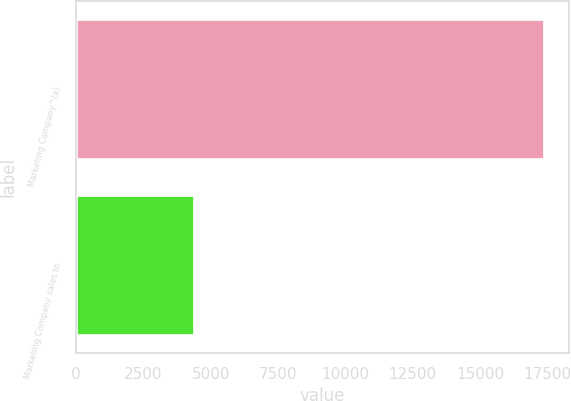Convert chart. <chart><loc_0><loc_0><loc_500><loc_500><bar_chart><fcel>Marketing Company^(a)<fcel>Marketing Company sales to<nl><fcel>17425<fcel>4418.6<nl></chart> 